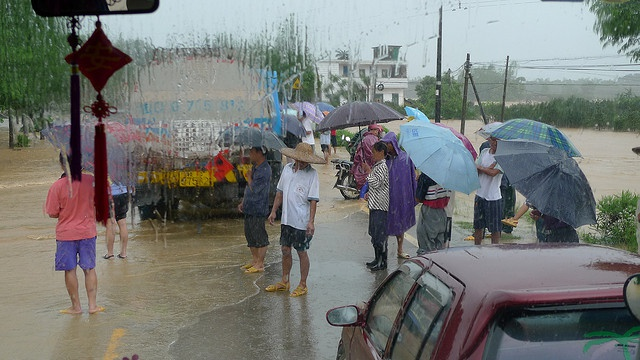Describe the objects in this image and their specific colors. I can see car in darkgreen, gray, black, and teal tones, truck in darkgreen, darkgray, black, and gray tones, umbrella in darkgreen, gray, and darkblue tones, people in darkgreen, brown, purple, and gray tones, and people in darkgreen, darkgray, gray, and black tones in this image. 